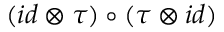<formula> <loc_0><loc_0><loc_500><loc_500>( i d \otimes \tau ) \circ ( \tau \otimes i d )</formula> 